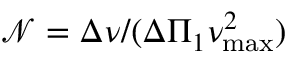Convert formula to latex. <formula><loc_0><loc_0><loc_500><loc_500>\mathcal { N } = \Delta \nu / ( \Delta \Pi _ { 1 } \nu _ { \max } ^ { 2 } )</formula> 